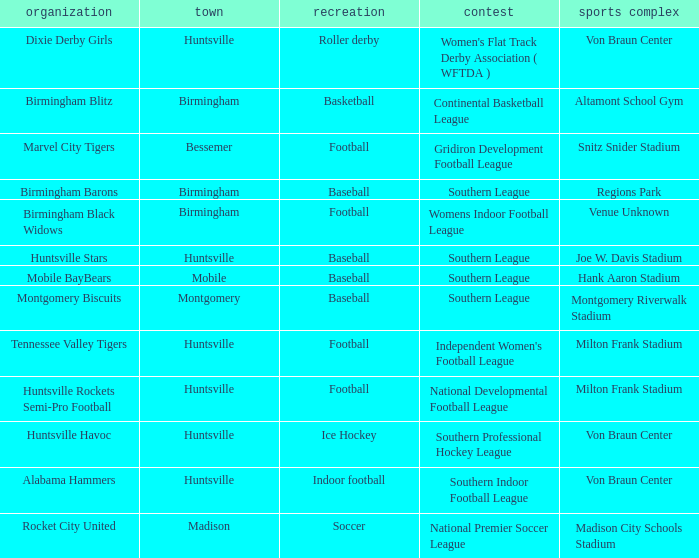Could you help me parse every detail presented in this table? {'header': ['organization', 'town', 'recreation', 'contest', 'sports complex'], 'rows': [['Dixie Derby Girls', 'Huntsville', 'Roller derby', "Women's Flat Track Derby Association ( WFTDA )", 'Von Braun Center'], ['Birmingham Blitz', 'Birmingham', 'Basketball', 'Continental Basketball League', 'Altamont School Gym'], ['Marvel City Tigers', 'Bessemer', 'Football', 'Gridiron Development Football League', 'Snitz Snider Stadium'], ['Birmingham Barons', 'Birmingham', 'Baseball', 'Southern League', 'Regions Park'], ['Birmingham Black Widows', 'Birmingham', 'Football', 'Womens Indoor Football League', 'Venue Unknown'], ['Huntsville Stars', 'Huntsville', 'Baseball', 'Southern League', 'Joe W. Davis Stadium'], ['Mobile BayBears', 'Mobile', 'Baseball', 'Southern League', 'Hank Aaron Stadium'], ['Montgomery Biscuits', 'Montgomery', 'Baseball', 'Southern League', 'Montgomery Riverwalk Stadium'], ['Tennessee Valley Tigers', 'Huntsville', 'Football', "Independent Women's Football League", 'Milton Frank Stadium'], ['Huntsville Rockets Semi-Pro Football', 'Huntsville', 'Football', 'National Developmental Football League', 'Milton Frank Stadium'], ['Huntsville Havoc', 'Huntsville', 'Ice Hockey', 'Southern Professional Hockey League', 'Von Braun Center'], ['Alabama Hammers', 'Huntsville', 'Indoor football', 'Southern Indoor Football League', 'Von Braun Center'], ['Rocket City United', 'Madison', 'Soccer', 'National Premier Soccer League', 'Madison City Schools Stadium']]} Which venue hosted the Gridiron Development Football League? Snitz Snider Stadium. 